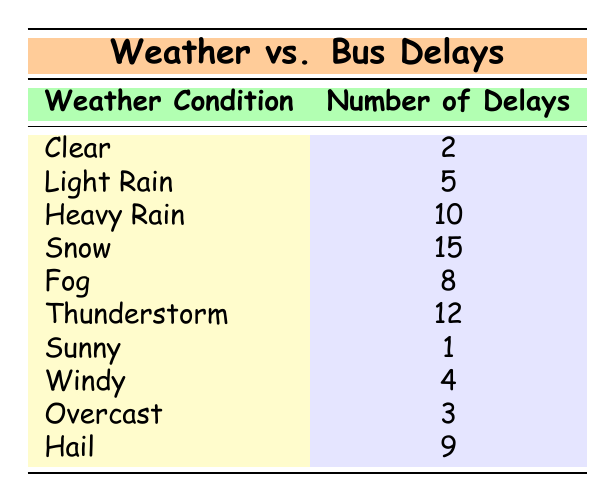What is the number of delays during Snow weather? According to the table, the row for Snow shows that the number of delays is 15.
Answer: 15 Which weather condition has the highest number of delays? By reviewing the table, Snow has the highest number of delays with 15, more than any other weather condition listed.
Answer: Snow Is there more than one weather condition that causes less than 5 delays? In the table, both Clear (2) and Sunny (1) have less than 5 delays, making the statement true.
Answer: Yes What is the average number of delays across all weather conditions? To find the average, sum the number of delays for each condition: 2 + 5 + 10 + 15 + 8 + 12 + 1 + 4 + 3 + 9 = 69. Then, divide this by the total number of weather conditions, which is 10: 69/10 = 6.9.
Answer: 6.9 How many more delays are there during Heavy Rain compared to Light Rain? According to the table, Heavy Rain has 10 delays while Light Rain has 5. The difference is 10 - 5 = 5.
Answer: 5 Does Fog have more delays than Windy weather? In the table, Fog has 8 delays and Windy has 4 delays; hence Fog does have more delays than Windy.
Answer: Yes What is the total number of delays from Thunderstorm and Hail combined? In the table, Thunderstorm has 12 delays and Hail has 9. Adding these together gives 12 + 9 = 21.
Answer: 21 Is Clear weather correlated with the least number of delays? Based on the table, Clear weather has 2 delays, which is the lowest number of delays compared to all other conditions, affirming the correlation.
Answer: Yes Which weather conditions have a number of delays greater than 8? The conditions with delays greater than 8 are Snow (15), Thunderstorm (12), and Hail (9), as evidenced by reviewing the numerical values in the table.
Answer: Snow, Thunderstorm, Hail 